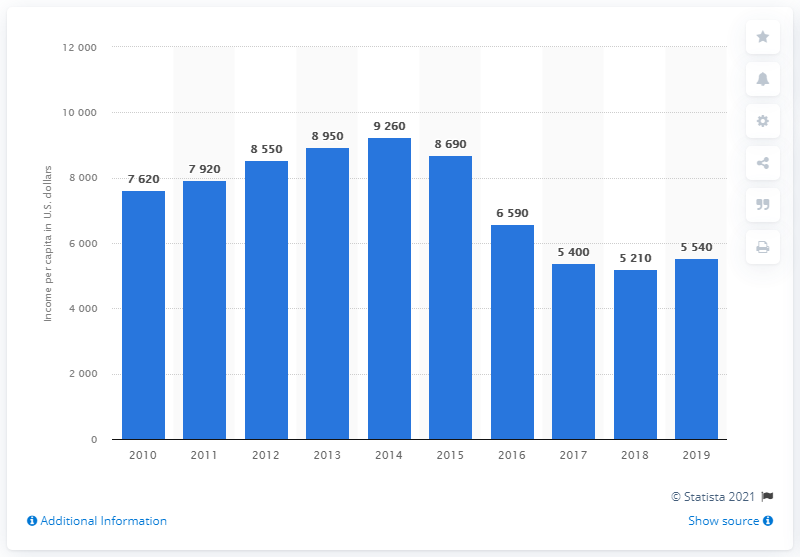Mention a couple of crucial points in this snapshot. In 2019, the national gross income per capita in Suriname was $5,540. In the previous year, the national gross income per person in Suriname was 5,210. 